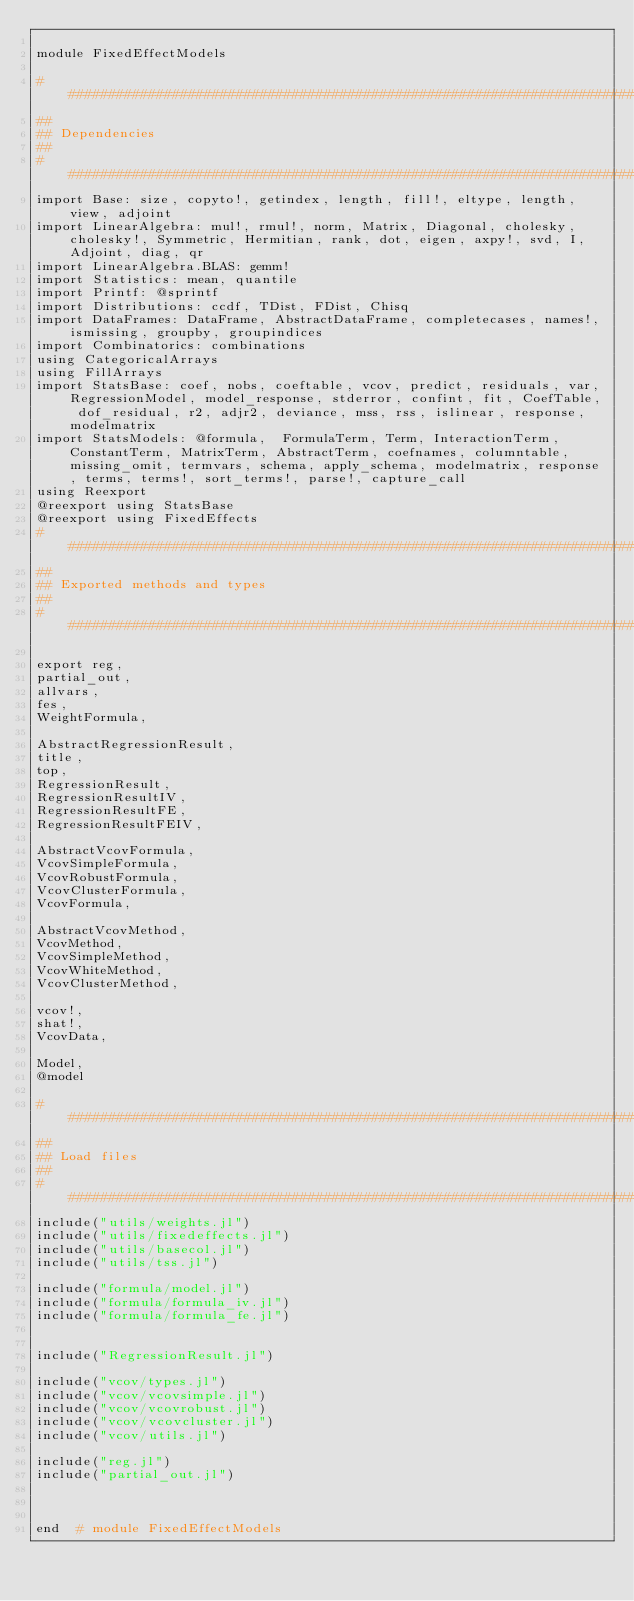Convert code to text. <code><loc_0><loc_0><loc_500><loc_500><_Julia_>
module FixedEffectModels

##############################################################################
##
## Dependencies
##
##############################################################################
import Base: size, copyto!, getindex, length, fill!, eltype, length, view, adjoint
import LinearAlgebra: mul!, rmul!, norm, Matrix, Diagonal, cholesky, cholesky!, Symmetric, Hermitian, rank, dot, eigen, axpy!, svd, I, Adjoint, diag, qr
import LinearAlgebra.BLAS: gemm!
import Statistics: mean, quantile
import Printf: @sprintf
import Distributions: ccdf, TDist, FDist, Chisq
import DataFrames: DataFrame, AbstractDataFrame, completecases, names!, ismissing, groupby, groupindices
import Combinatorics: combinations
using CategoricalArrays
using FillArrays
import StatsBase: coef, nobs, coeftable, vcov, predict, residuals, var, RegressionModel, model_response, stderror, confint, fit, CoefTable, dof_residual, r2, adjr2, deviance, mss, rss, islinear, response, modelmatrix
import StatsModels: @formula,  FormulaTerm, Term, InteractionTerm, ConstantTerm, MatrixTerm, AbstractTerm, coefnames, columntable, missing_omit, termvars, schema, apply_schema, modelmatrix, response, terms, terms!, sort_terms!, parse!, capture_call
using Reexport
@reexport using StatsBase
@reexport using FixedEffects
##############################################################################
##
## Exported methods and types
##
##############################################################################

export reg,
partial_out,
allvars,
fes,
WeightFormula,

AbstractRegressionResult,
title,
top,
RegressionResult,
RegressionResultIV,
RegressionResultFE,
RegressionResultFEIV,

AbstractVcovFormula,
VcovSimpleFormula,
VcovRobustFormula,
VcovClusterFormula,
VcovFormula,

AbstractVcovMethod,
VcovMethod,
VcovSimpleMethod,
VcovWhiteMethod,
VcovClusterMethod,

vcov!,
shat!,
VcovData,

Model,
@model

##############################################################################
##
## Load files
##
##############################################################################
include("utils/weights.jl")
include("utils/fixedeffects.jl")
include("utils/basecol.jl")
include("utils/tss.jl")

include("formula/model.jl")
include("formula/formula_iv.jl")
include("formula/formula_fe.jl")


include("RegressionResult.jl")

include("vcov/types.jl")
include("vcov/vcovsimple.jl")
include("vcov/vcovrobust.jl")
include("vcov/vcovcluster.jl")
include("vcov/utils.jl")

include("reg.jl")
include("partial_out.jl")



end  # module FixedEffectModels
</code> 